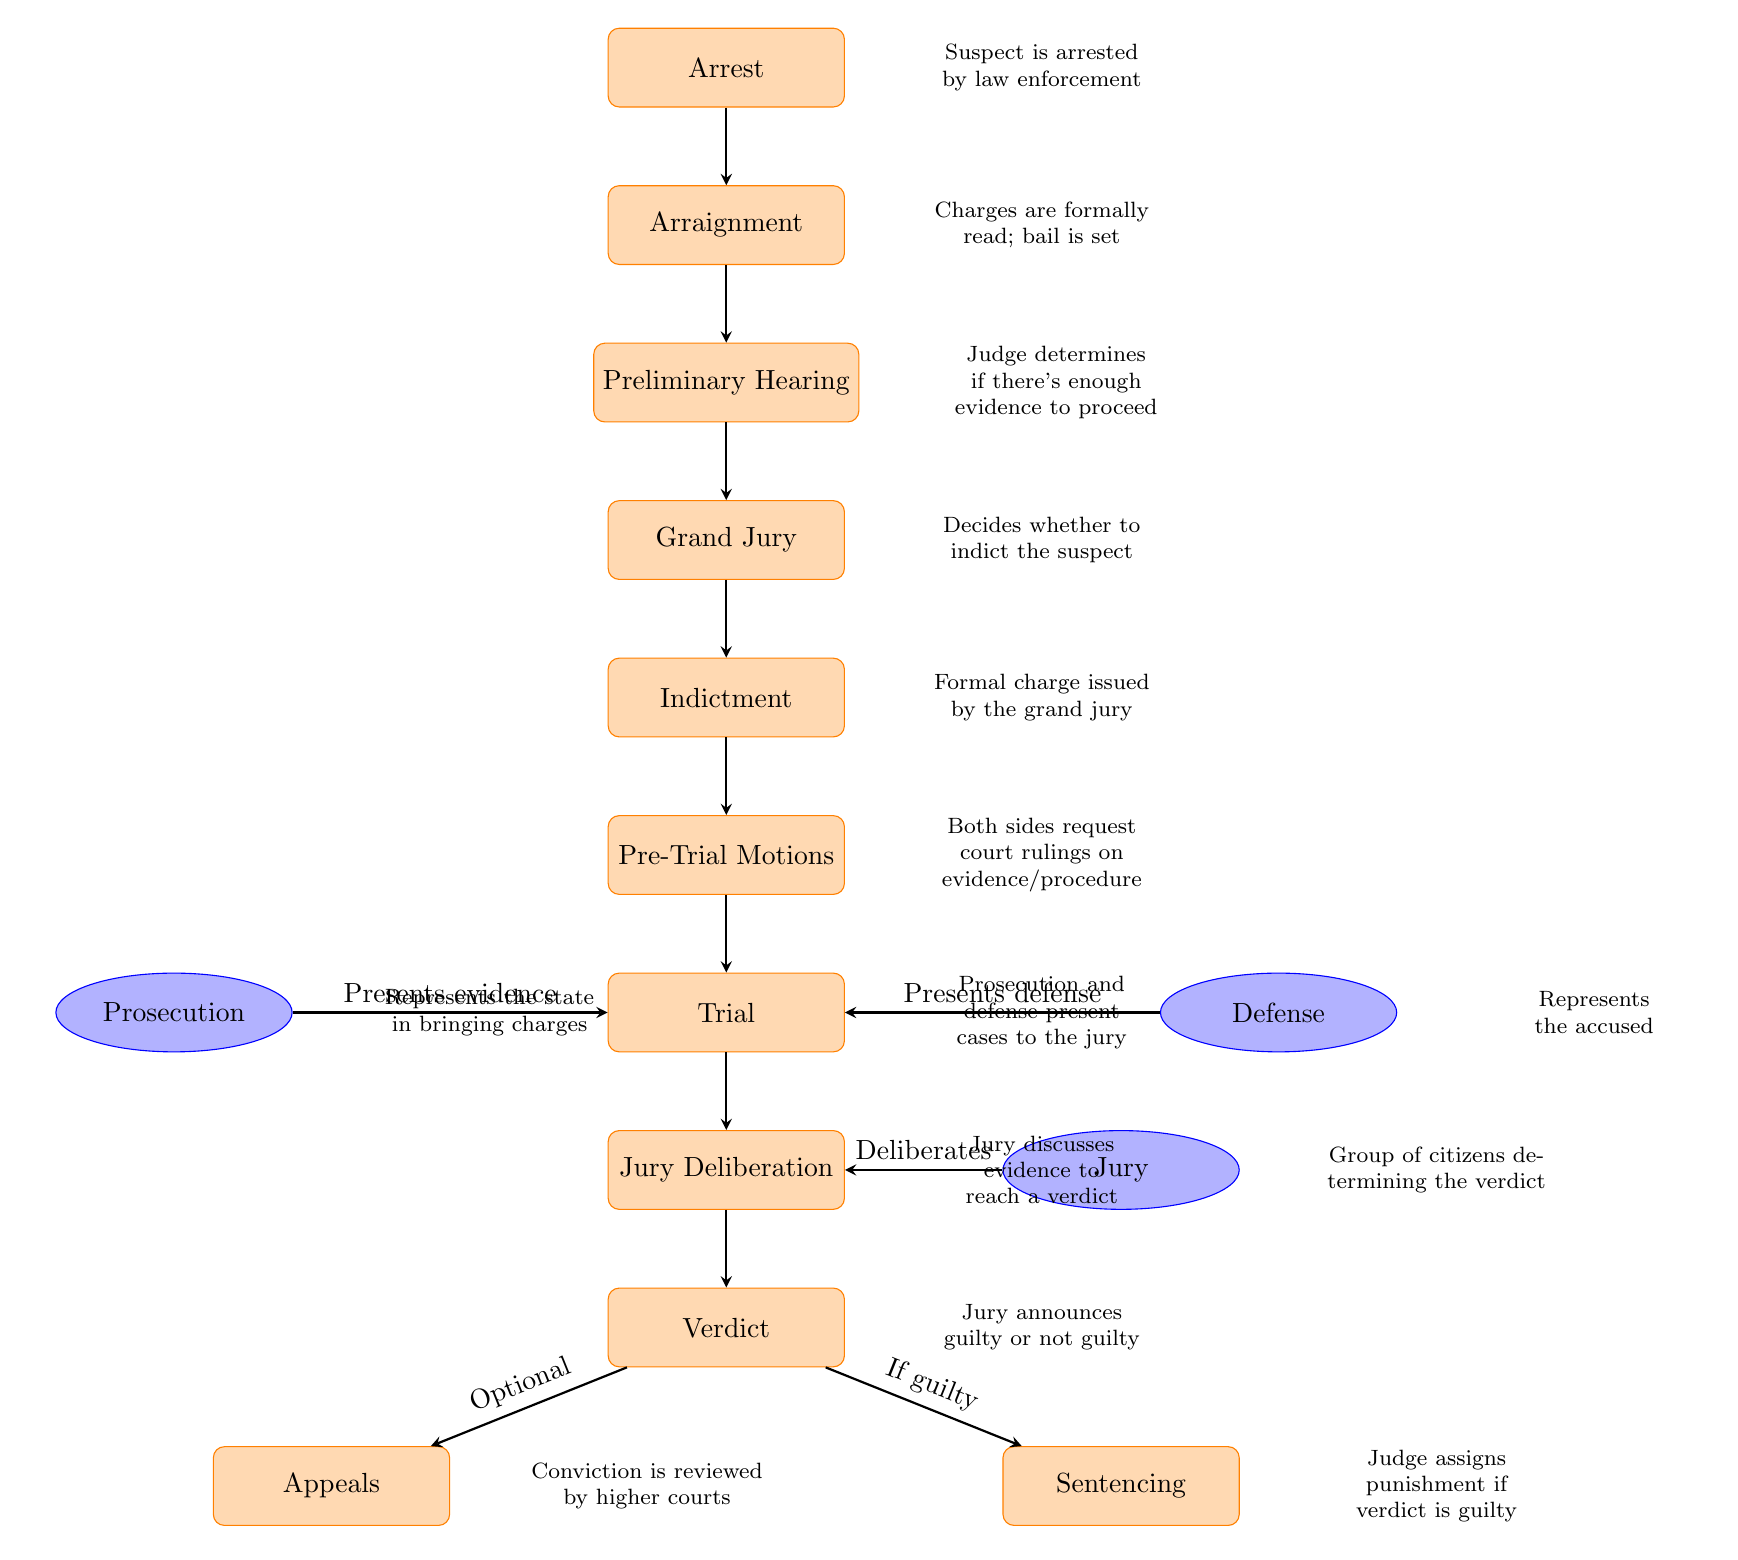What is the first stage in the judicial process? The diagram indicates that the first stage is "Arrest," which is the initial action taken by law enforcement against a suspect.
Answer: Arrest What comes after the Grand Jury? Following the "Grand Jury" stage, the next step is "Indictment," where a formal charge is issued based on the grand jury's decision.
Answer: Indictment How many main process nodes are depicted in the diagram? The main process nodes include Arrest, Arraignment, Preliminary Hearing, Grand Jury, Indictment, Pre-Trial Motions, Trial, Jury Deliberation, Verdict, Sentencing, and Appeals, totaling eleven nodes.
Answer: 11 What role does the Prosecution play during the Trial? During the "Trial," the Prosecution presents evidence to support the charges against the accused.
Answer: Presents evidence What happens if the Verdict is guilty? According to the diagram, if the "Verdict" is guilty, the process continues to "Sentencing," where the judge assigns punishment.
Answer: Sentencing What is the relationship between Arraignment and Preliminary Hearing? The "Arraignment" leads directly to the "Preliminary Hearing," indicating a sequential flow from one stage to the next in the judicial process.
Answer: Sequential flow Which actor is involved in the Jury Deliberation? The "Jury" is involved in "Jury Deliberation," where they discuss the evidence presented in court before reaching a verdict.
Answer: Jury What option is available after the Verdict? After the "Verdict," there is an option for "Appeals," where a conviction can be reviewed by higher courts.
Answer: Appeals What is the purpose of a Preliminary Hearing? The purpose of the "Preliminary Hearing" is for the judge to determine if there is enough evidence to proceed with the case, which is crucial in the judicial process.
Answer: Enough evidence determination 